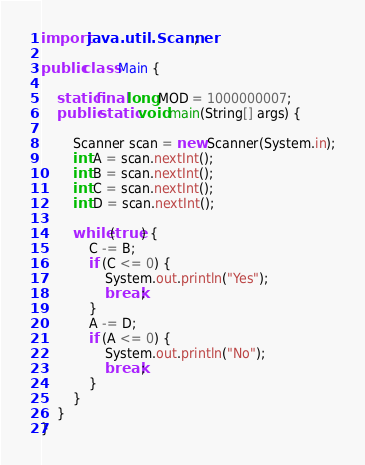<code> <loc_0><loc_0><loc_500><loc_500><_Java_>import java.util.Scanner;

public class Main {

	static final long MOD = 1000000007;
	public static void main(String[] args) {

		Scanner scan = new Scanner(System.in);
		int A = scan.nextInt();
		int B = scan.nextInt();
		int C = scan.nextInt();
		int D = scan.nextInt();

		while (true) {
			C -= B;
			if (C <= 0) {
				System.out.println("Yes");
				break;
			}
			A -= D;
			if (A <= 0) {
				System.out.println("No");
				break;
			}
		}
	}
}</code> 